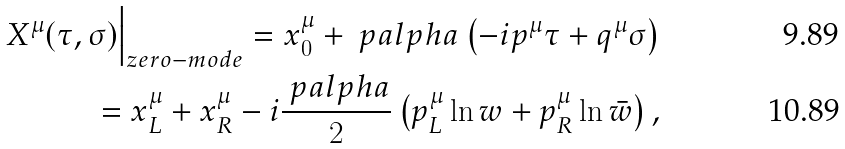<formula> <loc_0><loc_0><loc_500><loc_500>X ^ { \mu } ( \tau , \sigma ) \Big | _ { z e r o - m o d e } = x _ { 0 } ^ { \mu } + \ p a l p h a \left ( - i p ^ { \mu } \tau + q ^ { \mu } \sigma \right ) \\ = x ^ { \mu } _ { L } + x ^ { \mu } _ { R } - i \frac { \ p a l p h a } { 2 } \left ( p ^ { \mu } _ { L } \ln w + p ^ { \mu } _ { R } \ln \bar { w } \right ) ,</formula> 